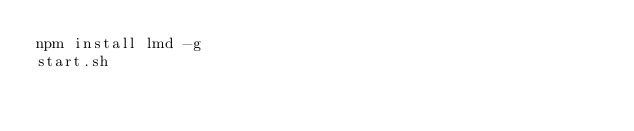<code> <loc_0><loc_0><loc_500><loc_500><_Bash_>npm install lmd -g
start.sh</code> 